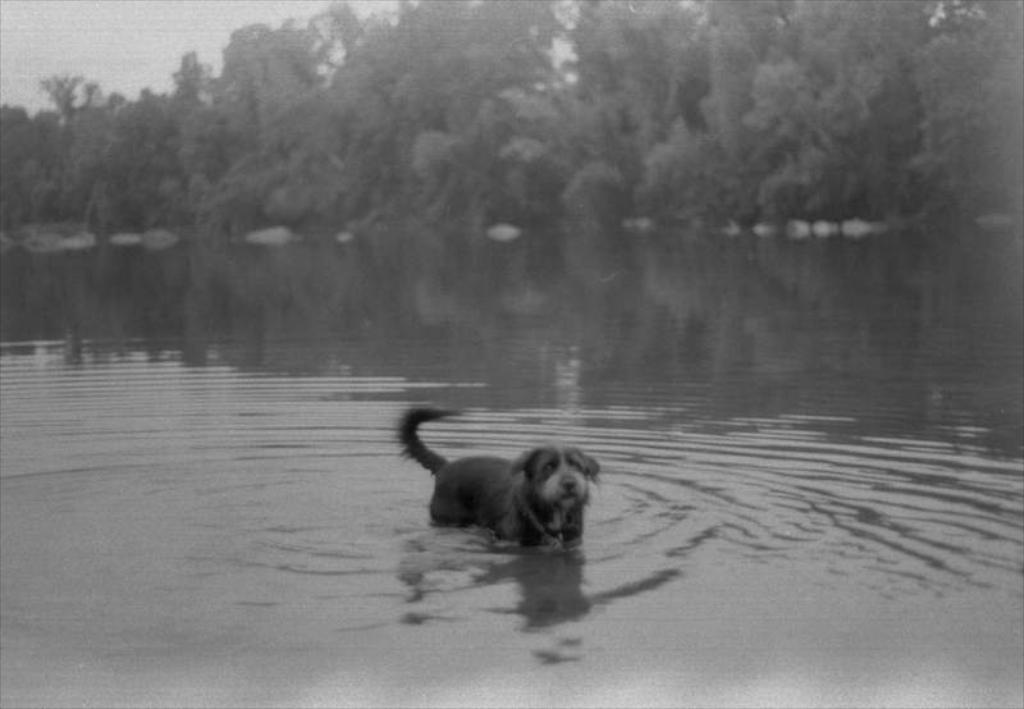What animal is in the water in the image? There is a dog in the water in the image. What can be seen in the background of the image? There are trees in the background of the image. What is the color scheme of the image? The image is black and white. What type of brush is being used to paint the van in the image? There is no brush or van present in the image; it features a dog in the water and trees in the background, all in black and white. 